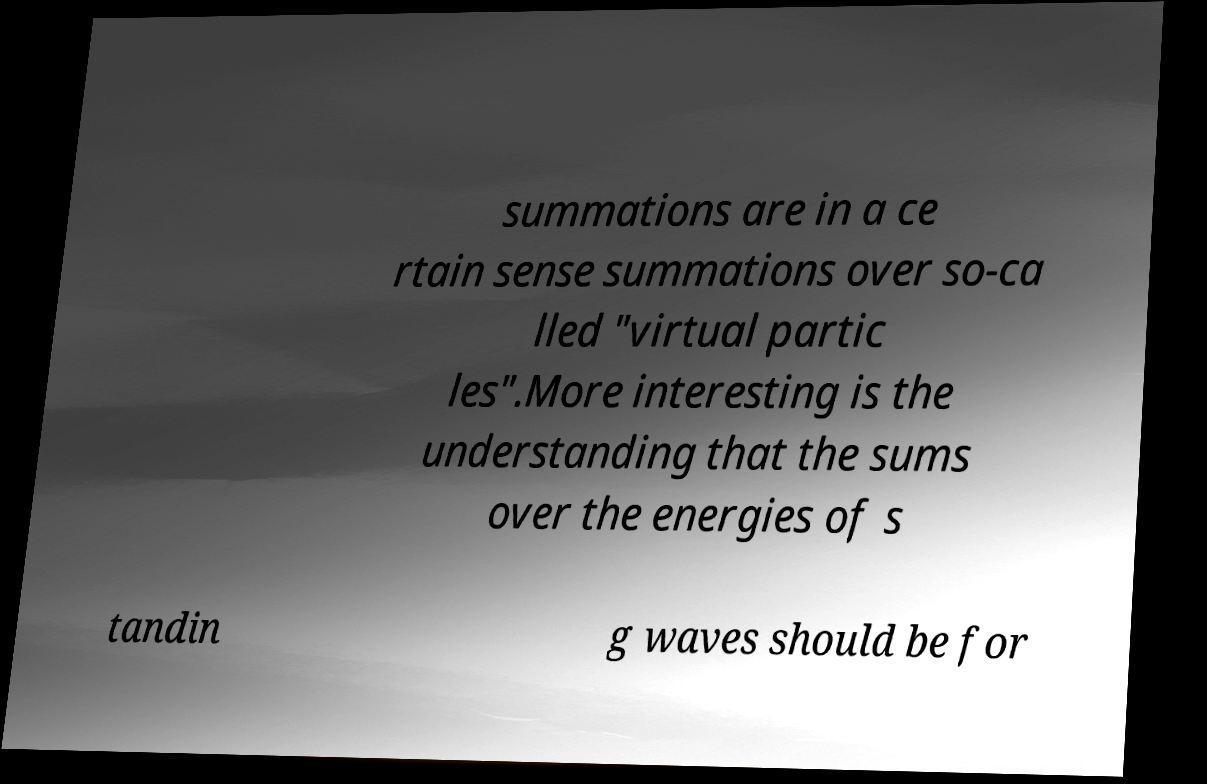What messages or text are displayed in this image? I need them in a readable, typed format. summations are in a ce rtain sense summations over so-ca lled "virtual partic les".More interesting is the understanding that the sums over the energies of s tandin g waves should be for 